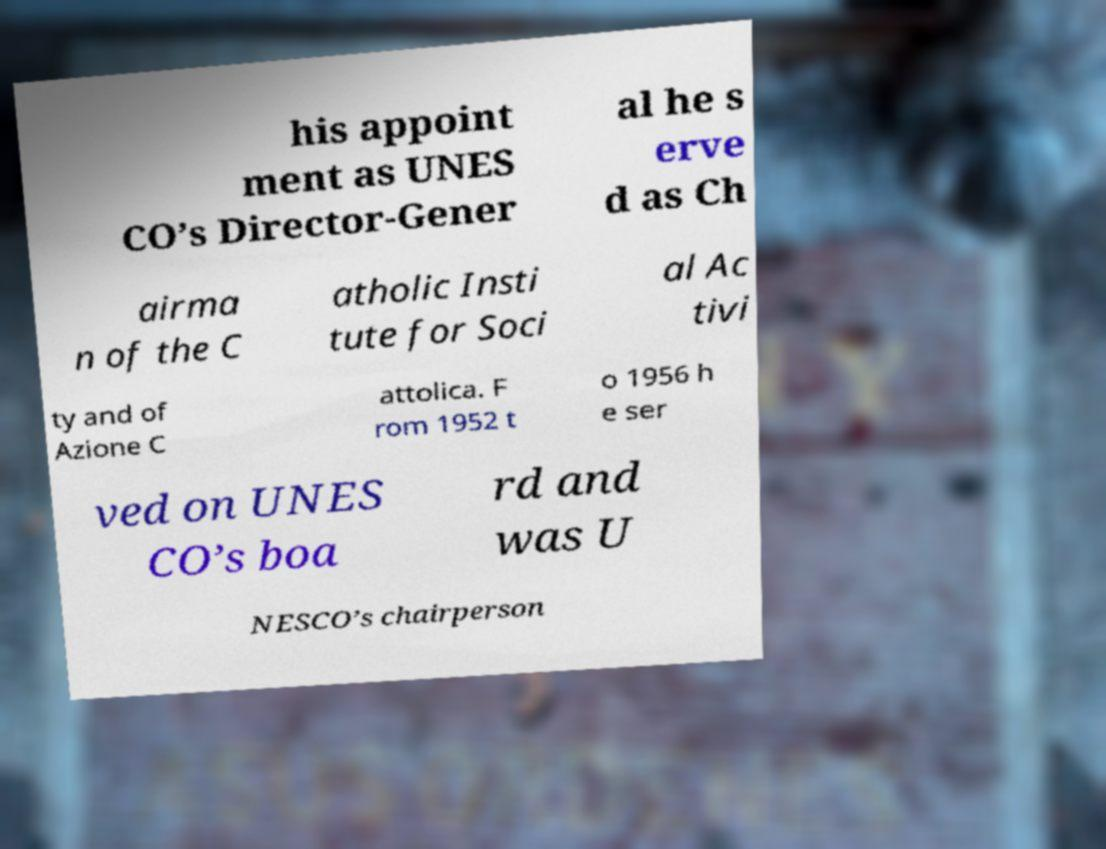I need the written content from this picture converted into text. Can you do that? his appoint ment as UNES CO’s Director-Gener al he s erve d as Ch airma n of the C atholic Insti tute for Soci al Ac tivi ty and of Azione C attolica. F rom 1952 t o 1956 h e ser ved on UNES CO’s boa rd and was U NESCO’s chairperson 